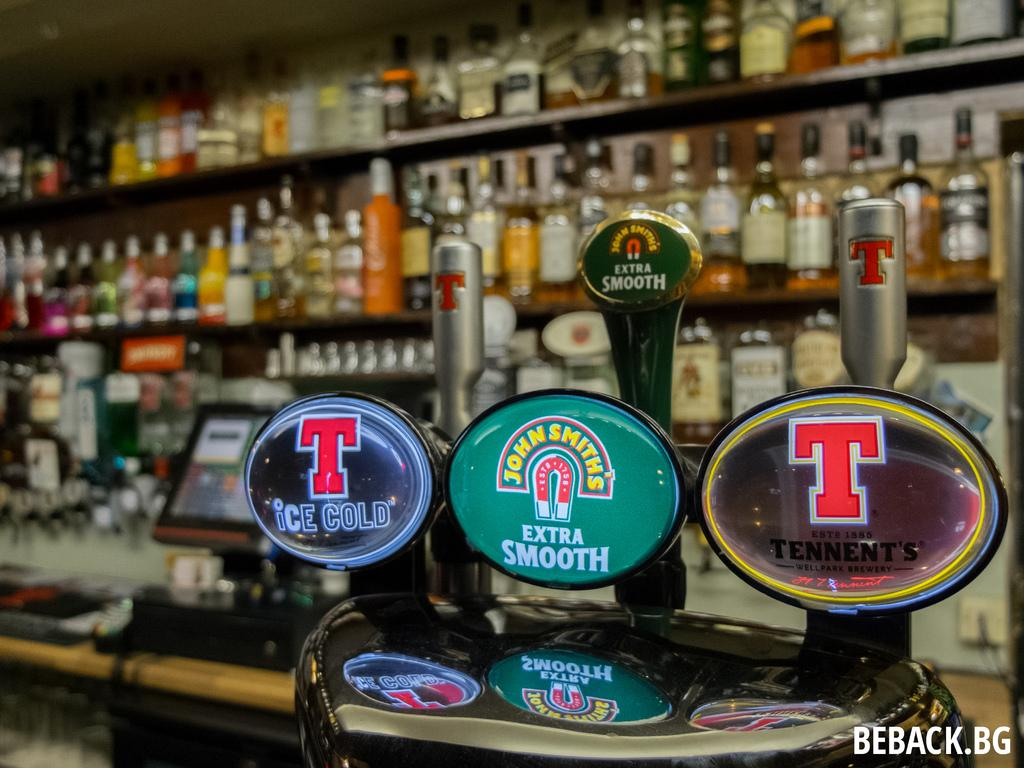Provide a one-sentence caption for the provided image. beback.bg  is sponsoring a liquor store, with shelves full of different alcohol and beer taps. 